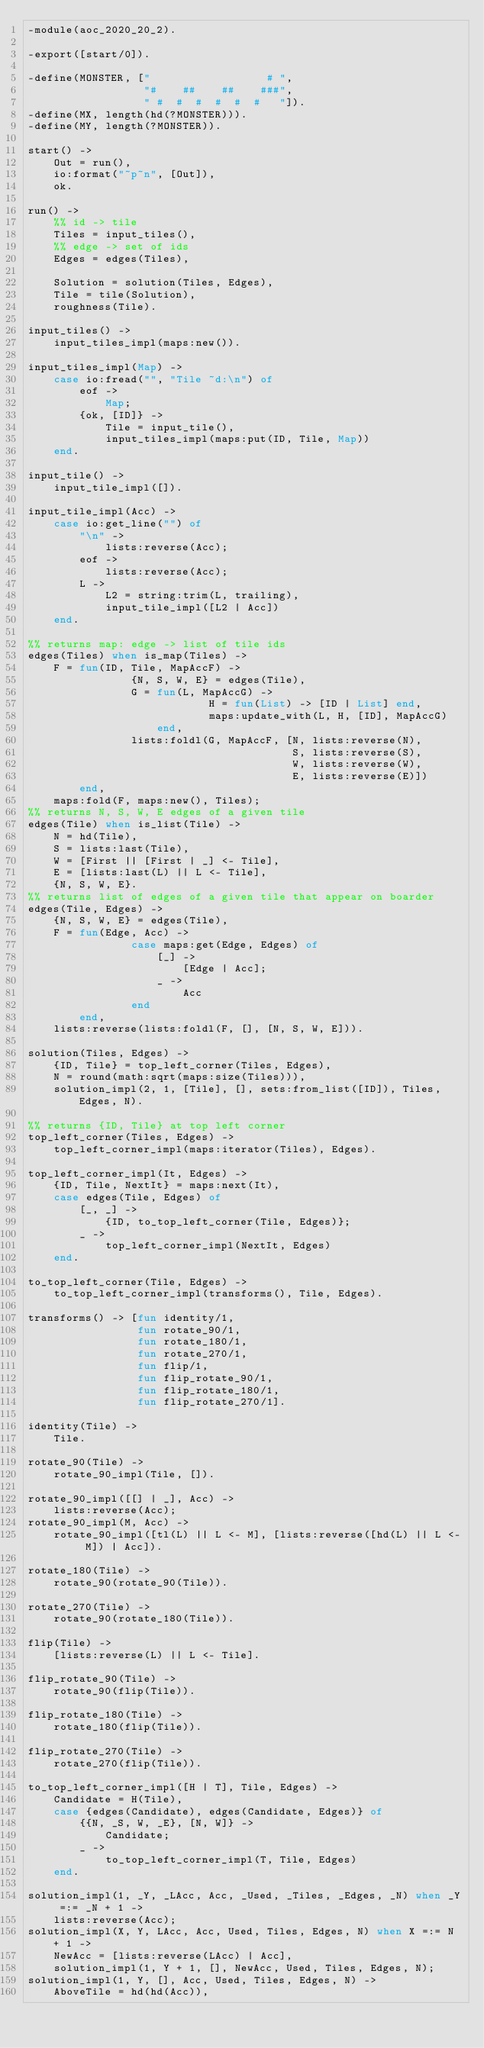Convert code to text. <code><loc_0><loc_0><loc_500><loc_500><_Erlang_>-module(aoc_2020_20_2).

-export([start/0]).

-define(MONSTER, ["                  # ",
                  "#    ##    ##    ###",
                  " #  #  #  #  #  #   "]).
-define(MX, length(hd(?MONSTER))).
-define(MY, length(?MONSTER)).

start() ->
    Out = run(),
    io:format("~p~n", [Out]),
    ok.

run() ->
    %% id -> tile
    Tiles = input_tiles(),
    %% edge -> set of ids
    Edges = edges(Tiles),

    Solution = solution(Tiles, Edges),
    Tile = tile(Solution),
    roughness(Tile).

input_tiles() ->
    input_tiles_impl(maps:new()).

input_tiles_impl(Map) ->
    case io:fread("", "Tile ~d:\n") of
        eof ->
            Map;
        {ok, [ID]} ->
            Tile = input_tile(),
            input_tiles_impl(maps:put(ID, Tile, Map))
    end.

input_tile() ->
    input_tile_impl([]).

input_tile_impl(Acc) ->
    case io:get_line("") of
        "\n" ->
            lists:reverse(Acc);
        eof ->
            lists:reverse(Acc);
        L ->
            L2 = string:trim(L, trailing),
            input_tile_impl([L2 | Acc])
    end.

%% returns map: edge -> list of tile ids
edges(Tiles) when is_map(Tiles) ->
    F = fun(ID, Tile, MapAccF) ->
                {N, S, W, E} = edges(Tile),
                G = fun(L, MapAccG) ->
                            H = fun(List) -> [ID | List] end,
                            maps:update_with(L, H, [ID], MapAccG)
                    end,
                lists:foldl(G, MapAccF, [N, lists:reverse(N),
                                         S, lists:reverse(S),
                                         W, lists:reverse(W),
                                         E, lists:reverse(E)])
        end,
    maps:fold(F, maps:new(), Tiles);
%% returns N, S, W, E edges of a given tile
edges(Tile) when is_list(Tile) ->
    N = hd(Tile),
    S = lists:last(Tile),
    W = [First || [First | _] <- Tile],
    E = [lists:last(L) || L <- Tile],
    {N, S, W, E}.
%% returns list of edges of a given tile that appear on boarder
edges(Tile, Edges) ->
    {N, S, W, E} = edges(Tile),
    F = fun(Edge, Acc) ->
                case maps:get(Edge, Edges) of
                    [_] ->
                        [Edge | Acc];
                    _ ->
                        Acc
                end
        end,
    lists:reverse(lists:foldl(F, [], [N, S, W, E])).

solution(Tiles, Edges) ->
    {ID, Tile} = top_left_corner(Tiles, Edges),
    N = round(math:sqrt(maps:size(Tiles))),
    solution_impl(2, 1, [Tile], [], sets:from_list([ID]), Tiles, Edges, N).

%% returns {ID, Tile} at top left corner
top_left_corner(Tiles, Edges) ->
    top_left_corner_impl(maps:iterator(Tiles), Edges).

top_left_corner_impl(It, Edges) ->
    {ID, Tile, NextIt} = maps:next(It),
    case edges(Tile, Edges) of
        [_, _] ->
            {ID, to_top_left_corner(Tile, Edges)};
        _ ->
            top_left_corner_impl(NextIt, Edges)
    end.

to_top_left_corner(Tile, Edges) ->
    to_top_left_corner_impl(transforms(), Tile, Edges).

transforms() -> [fun identity/1,
                 fun rotate_90/1,
                 fun rotate_180/1,
                 fun rotate_270/1,
                 fun flip/1,
                 fun flip_rotate_90/1,
                 fun flip_rotate_180/1,
                 fun flip_rotate_270/1].

identity(Tile) ->
    Tile.

rotate_90(Tile) ->
    rotate_90_impl(Tile, []).

rotate_90_impl([[] | _], Acc) ->
    lists:reverse(Acc);
rotate_90_impl(M, Acc) ->
    rotate_90_impl([tl(L) || L <- M], [lists:reverse([hd(L) || L <- M]) | Acc]).

rotate_180(Tile) ->
    rotate_90(rotate_90(Tile)).

rotate_270(Tile) ->
    rotate_90(rotate_180(Tile)).

flip(Tile) ->
    [lists:reverse(L) || L <- Tile].

flip_rotate_90(Tile) ->
    rotate_90(flip(Tile)).

flip_rotate_180(Tile) ->
    rotate_180(flip(Tile)).

flip_rotate_270(Tile) ->
    rotate_270(flip(Tile)).

to_top_left_corner_impl([H | T], Tile, Edges) ->
    Candidate = H(Tile),
    case {edges(Candidate), edges(Candidate, Edges)} of
        {{N, _S, W, _E}, [N, W]} ->
            Candidate;
        _ ->
            to_top_left_corner_impl(T, Tile, Edges)
    end.

solution_impl(1, _Y, _LAcc, Acc, _Used, _Tiles, _Edges, _N) when _Y =:= _N + 1 ->
    lists:reverse(Acc);
solution_impl(X, Y, LAcc, Acc, Used, Tiles, Edges, N) when X =:= N + 1 ->
    NewAcc = [lists:reverse(LAcc) | Acc],
    solution_impl(1, Y + 1, [], NewAcc, Used, Tiles, Edges, N);
solution_impl(1, Y, [], Acc, Used, Tiles, Edges, N) ->
    AboveTile = hd(hd(Acc)),</code> 